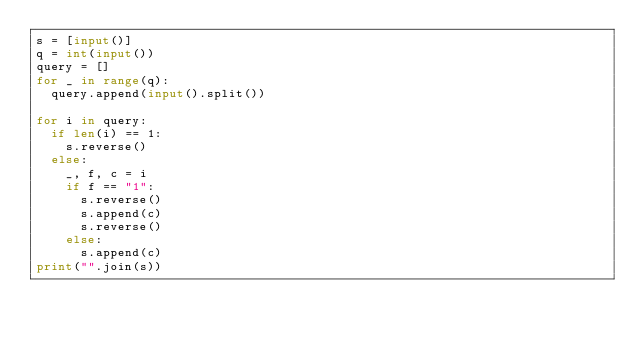<code> <loc_0><loc_0><loc_500><loc_500><_Python_>s = [input()]
q = int(input())
query = []
for _ in range(q):
  query.append(input().split())

for i in query:
  if len(i) == 1:
    s.reverse()
  else:
    _, f, c = i
    if f == "1":
      s.reverse()
      s.append(c)
      s.reverse()
    else:
      s.append(c)
print("".join(s))</code> 